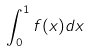Convert formula to latex. <formula><loc_0><loc_0><loc_500><loc_500>\int _ { 0 } ^ { 1 } f ( x ) d x</formula> 